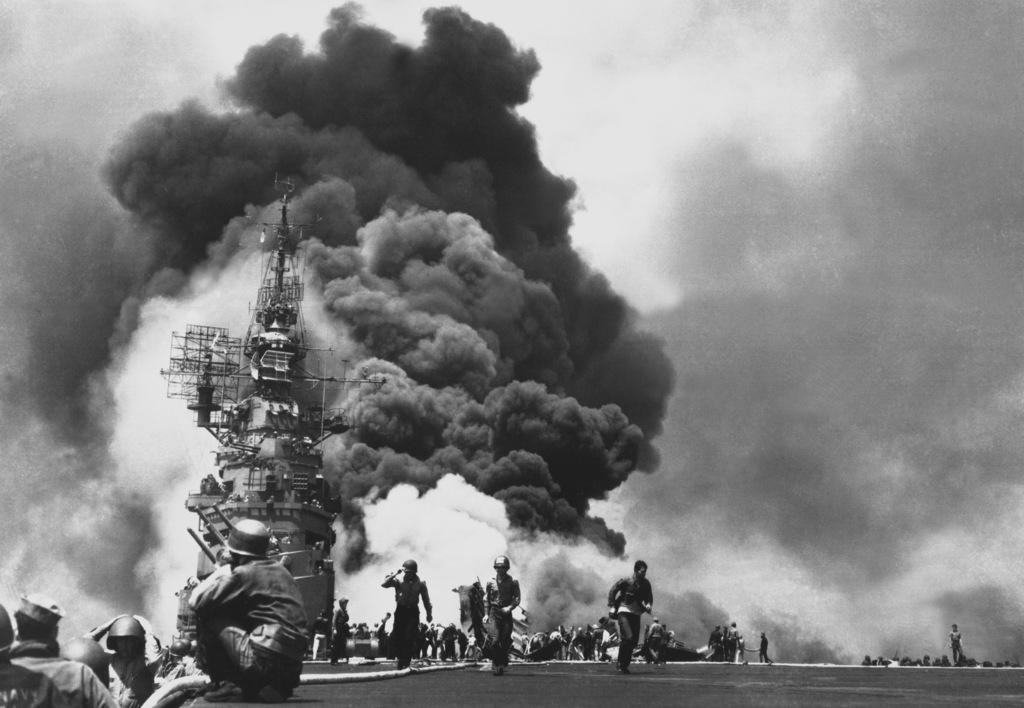How many people are in the image? There are people in the image, but the exact number is not specified. What are some of the people wearing? Some of the people are wearing helmets. What can be seen in the background of the image? There is smoke visible in the background of the image. What is the color scheme of the image? The image is black and white in color. Where is the lunchroom located in the image? There is no mention of a lunchroom in the image or the provided facts. Can you see any notes or written messages in the image? There is no mention of notes or written messages in the image or the provided facts. 